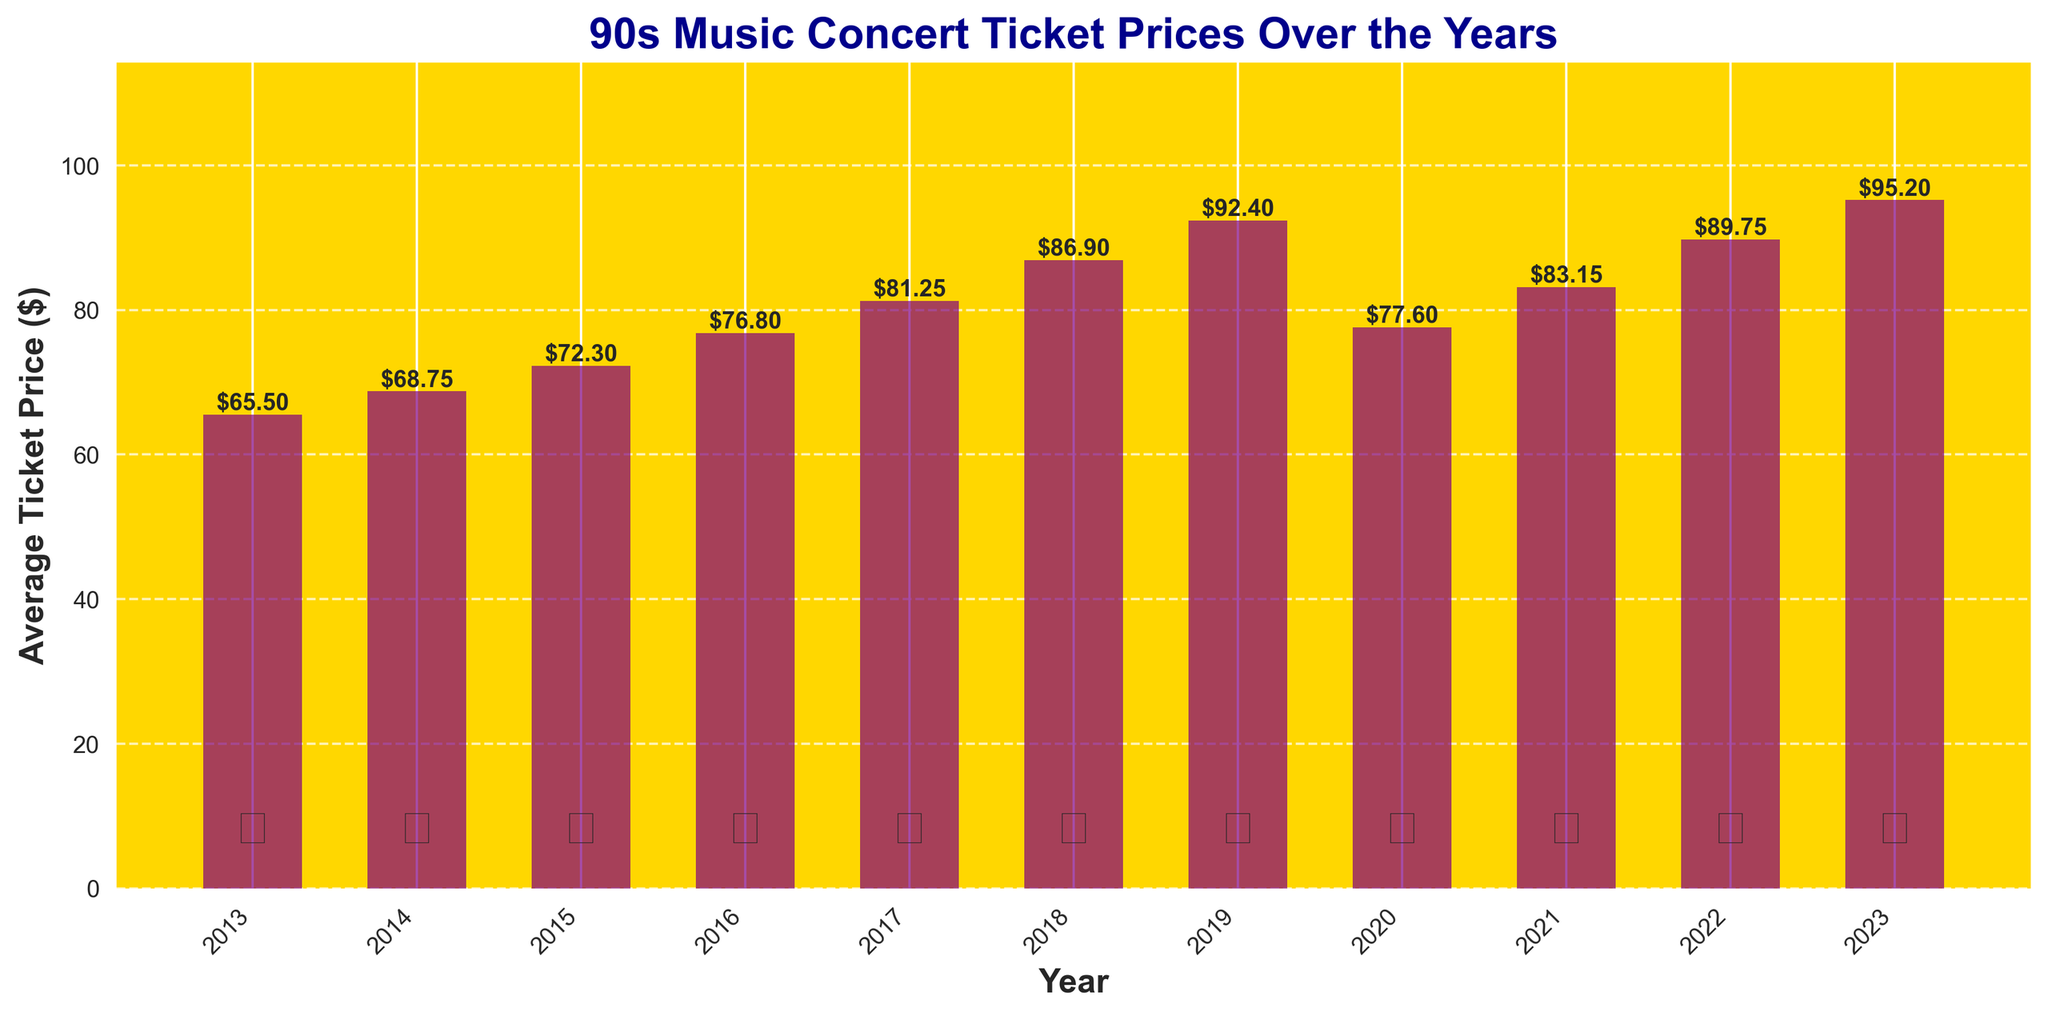What's the average ticket price in 2013 compared to 2023? To find the average ticket price for 2013 and compare it to 2023, look at the height of the bars labeled 2013 and 2023. In 2013, the price is $65.50, and in 2023, it is $95.20. Hence, the ticket price in 2023 is much higher than in 2013.
Answer: 2013: $65.50, 2023: $95.20 Which year had the highest average ticket price and what was it? Scan through the heights of all the bars. The bar for 2023 is visibly the tallest. The value at the top of this bar shows $95.20, indicating it had the highest average ticket price.
Answer: 2023, $95.20 How much did the average ticket price increase from 2019 to 2023? Find the heights of the bars for 2019 and 2023. The price in 2019 is $92.40, and in 2023 it is $95.20. The increase is calculated as $95.20 - $92.40 = $2.80.
Answer: $2.80 Which year saw the largest single-year drop in average ticket price and by how much? Check the bars year-over-year. The biggest drop appears between 2019 and 2020. In 2019, the price is $92.40, and in 2020 it is $77.60. The drop is $92.40 - $77.60 = $14.80.
Answer: 2020, $14.80 What is the trend of ticket prices from 2013 to 2019? Observe the general direction of the bars from 2013 to 2019. The bars keep increasing in height, indicating a consistent upward trend in ticket prices each year during this period.
Answer: Increasing trend How does the ticket price in 2021 compare to 2020? Look at the heights for the bars in 2020 and 2021. The bar in 2020 is at $77.60, while the bar in 2021 rises to $83.15. This indicates that the ticket price increased from 2020 to 2021.
Answer: Increased What is the difference in average ticket price between the lowest and highest years? The lowest ticket price is in 2013 at $65.50, and the highest is in 2023 at $95.20. Subtract the lowest from the highest to find the difference: $95.20 - $65.50 = $29.70.
Answer: $29.70 Between which consecutive years did the average ticket price show the smallest increase, and what was the increase? Examine the year-to-year changes. The smallest increase is between 2022 and 2023: $95.20 - $89.75 = $5.45.
Answer: 2022 and 2023, $5.45 Which year saw the average ticket price surpass $80 for the first time? Scan the heights to identify the year when the bar first exceeds $80. This occurs in 2017, where the average ticket price is $81.25.
Answer: 2017 What was the average ticket price in 2018 compared to 2020? Find the values for 2018 and 2020. In 2018, the price is $86.90, and in 2020 it is $77.60, indicating a decrease in ticket price.
Answer: 2018: $86.90, 2020: $77.60 